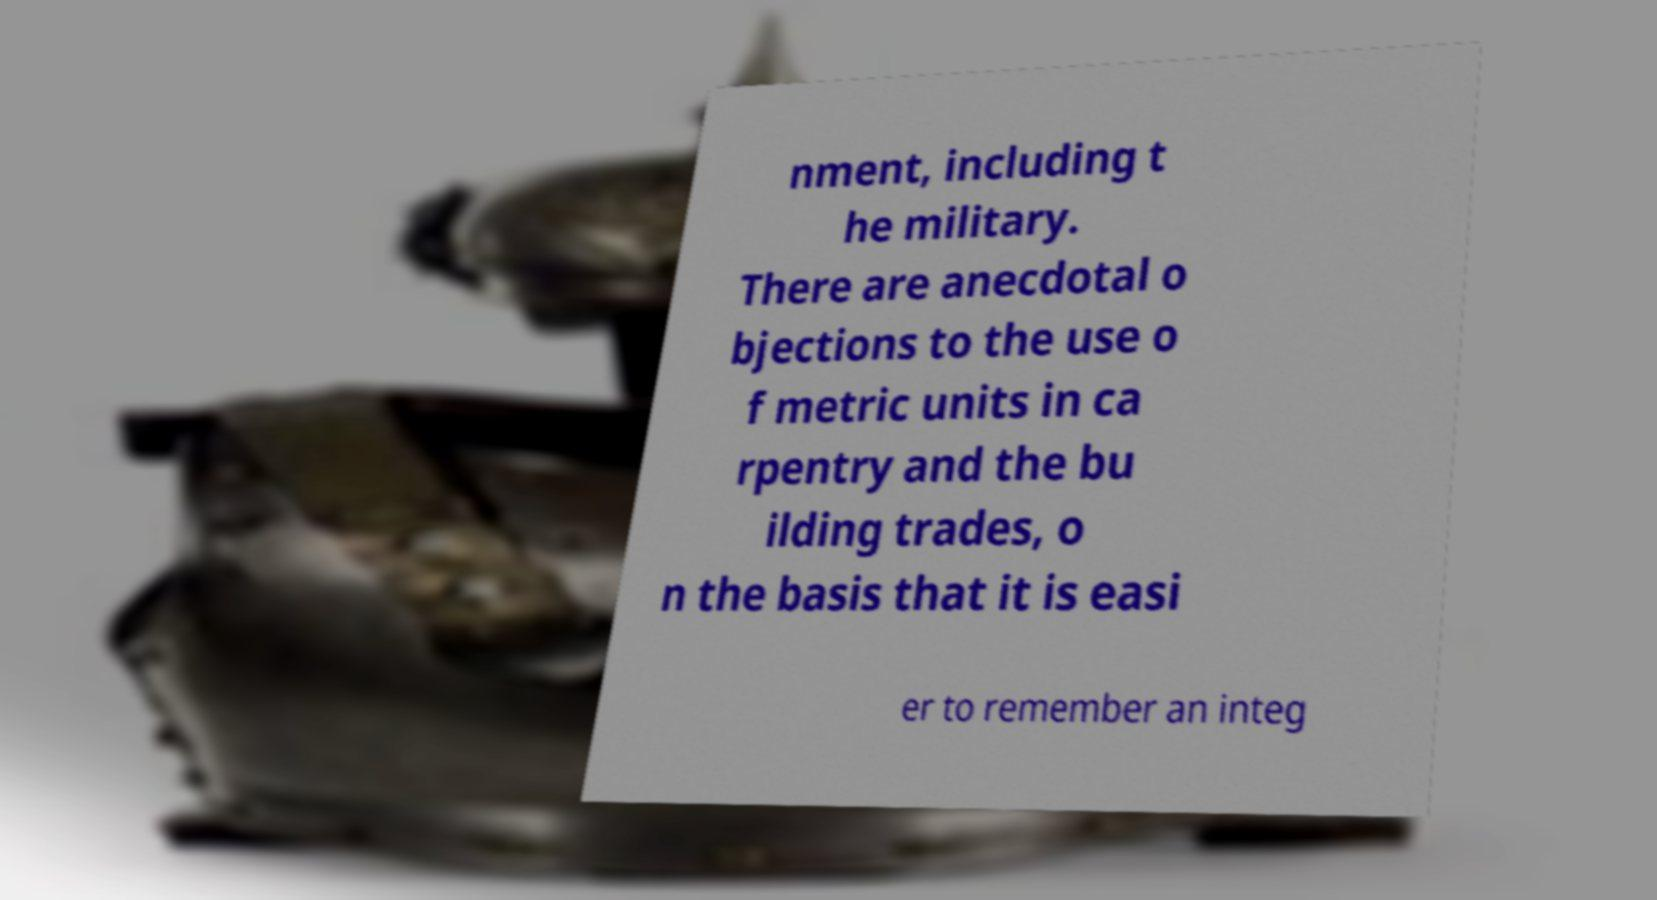Please read and relay the text visible in this image. What does it say? nment, including t he military. There are anecdotal o bjections to the use o f metric units in ca rpentry and the bu ilding trades, o n the basis that it is easi er to remember an integ 